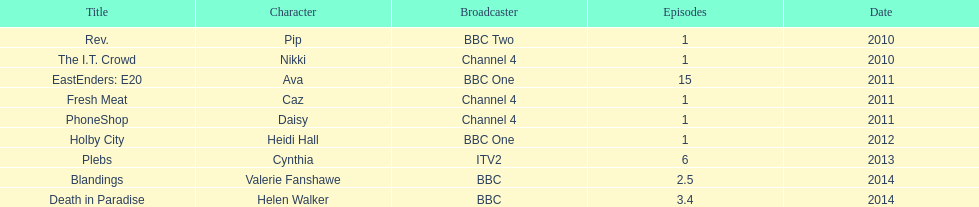Were there more than four episodes that featured cynthia? Yes. 